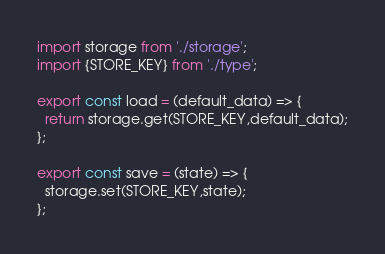<code> <loc_0><loc_0><loc_500><loc_500><_JavaScript_>import storage from './storage';
import {STORE_KEY} from './type';

export const load = (default_data) => {
  return storage.get(STORE_KEY,default_data);
};

export const save = (state) => {
  storage.set(STORE_KEY,state);
};
</code> 